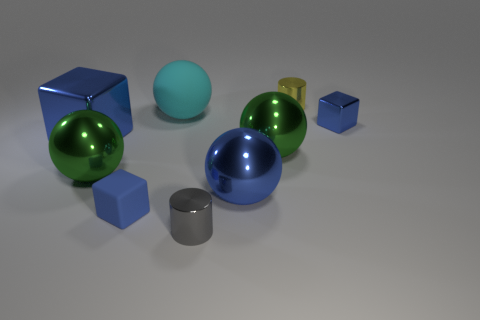What materials are the objects in the image likely made from? The objects in the image appear to be made of various materials, including rubber for the smaller, matte-finished balls, polished metal for the blue and green balls, and perhaps plastic or painted metal for the blue cubes. 